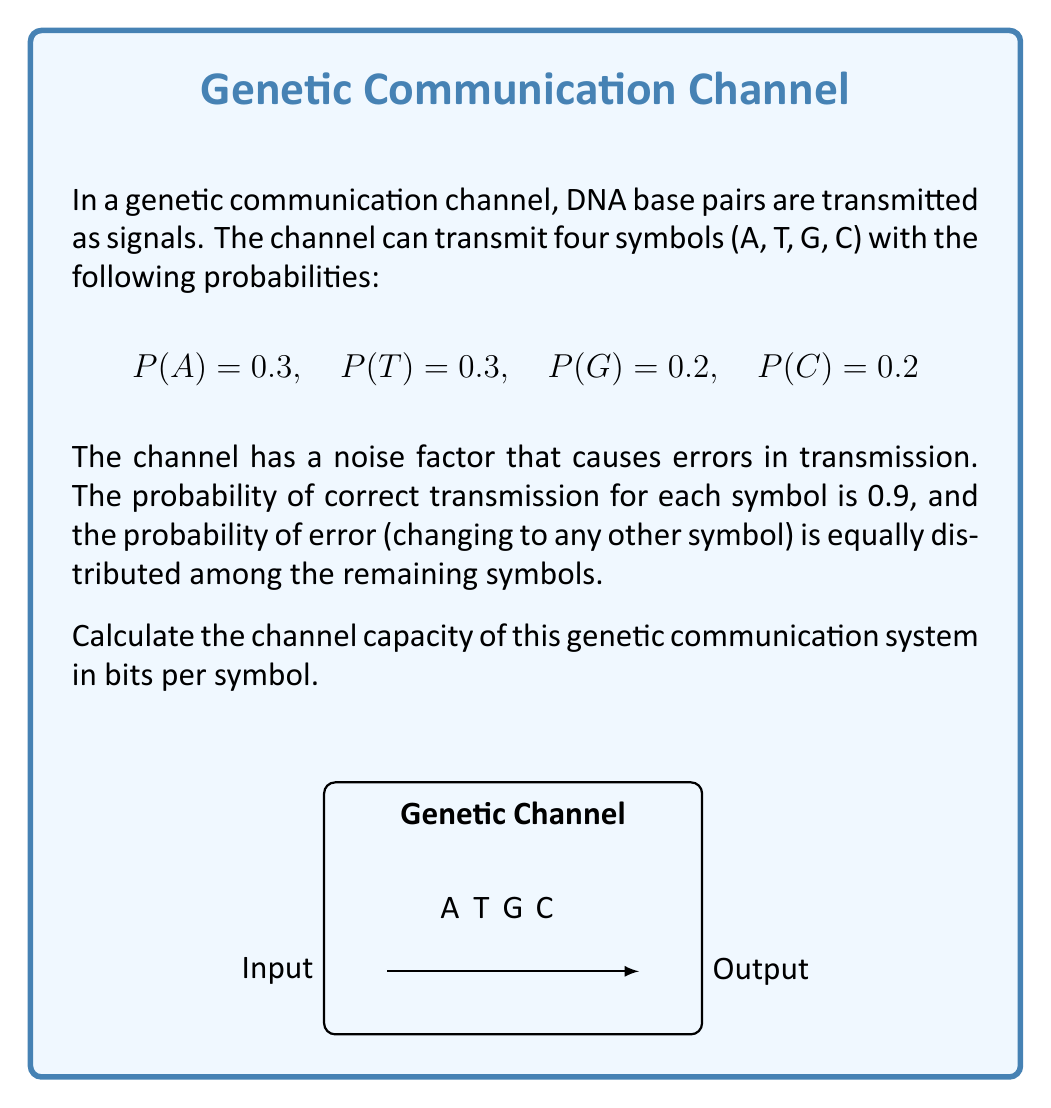Give your solution to this math problem. To determine the channel capacity, we need to follow these steps:

1) First, calculate the entropy of the input, H(X):

$$H(X) = -\sum_{i} p(x_i) \log_2 p(x_i)$$
$$H(X) = -(0.3 \log_2 0.3 + 0.3 \log_2 0.3 + 0.2 \log_2 0.2 + 0.2 \log_2 0.2)$$
$$H(X) \approx 1.9710 \text{ bits}$$

2) Next, calculate the conditional entropy H(Y|X), which represents the noise in the channel:

For each symbol, the probability of correct transmission is 0.9, and the probability of error (0.1) is equally distributed among the other three symbols (0.1/3 = 0.0333).

$$H(Y|X) = -\sum_{i} p(x_i) \sum_{j} p(y_j|x_i) \log_2 p(y_j|x_i)$$
$$H(Y|X) = -[4 \times (0.9 \log_2 0.9 + 3 \times 0.0333 \log_2 0.0333)]$$
$$H(Y|X) \approx 0.4690 \text{ bits}$$

3) The mutual information I(X;Y) is the difference between H(X) and H(Y|X):

$$I(X;Y) = H(X) - H(Y|X)$$
$$I(X;Y) = 1.9710 - 0.4690 = 1.5020 \text{ bits}$$

4) The channel capacity C is the maximum of I(X;Y) over all possible input distributions. In this case, the given distribution is already optimal (uniform for pairs A-T and G-C), so:

$$C = \max_{p(x)} I(X;Y) = 1.5020 \text{ bits per symbol}$$
Answer: 1.5020 bits per symbol 